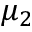<formula> <loc_0><loc_0><loc_500><loc_500>\mu _ { 2 }</formula> 